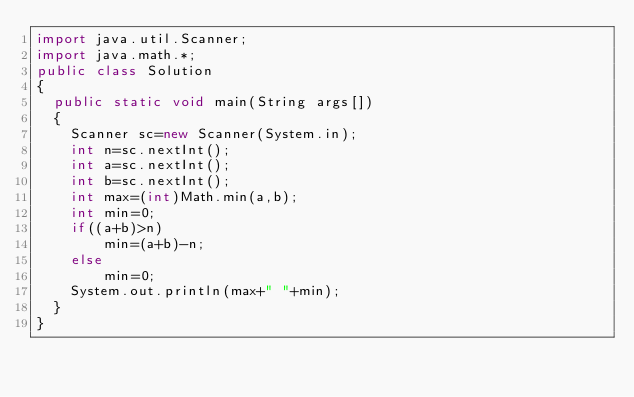Convert code to text. <code><loc_0><loc_0><loc_500><loc_500><_Java_>import java.util.Scanner;
import java.math.*;
public class Solution
{
  public static void main(String args[])
  {
    Scanner sc=new Scanner(System.in);
    int n=sc.nextInt();
    int a=sc.nextInt();
    int b=sc.nextInt();
    int max=(int)Math.min(a,b);
    int min=0;
    if((a+b)>n)
      	min=(a+b)-n;
   	else
      	min=0;
    System.out.println(max+" "+min);
  }
}</code> 